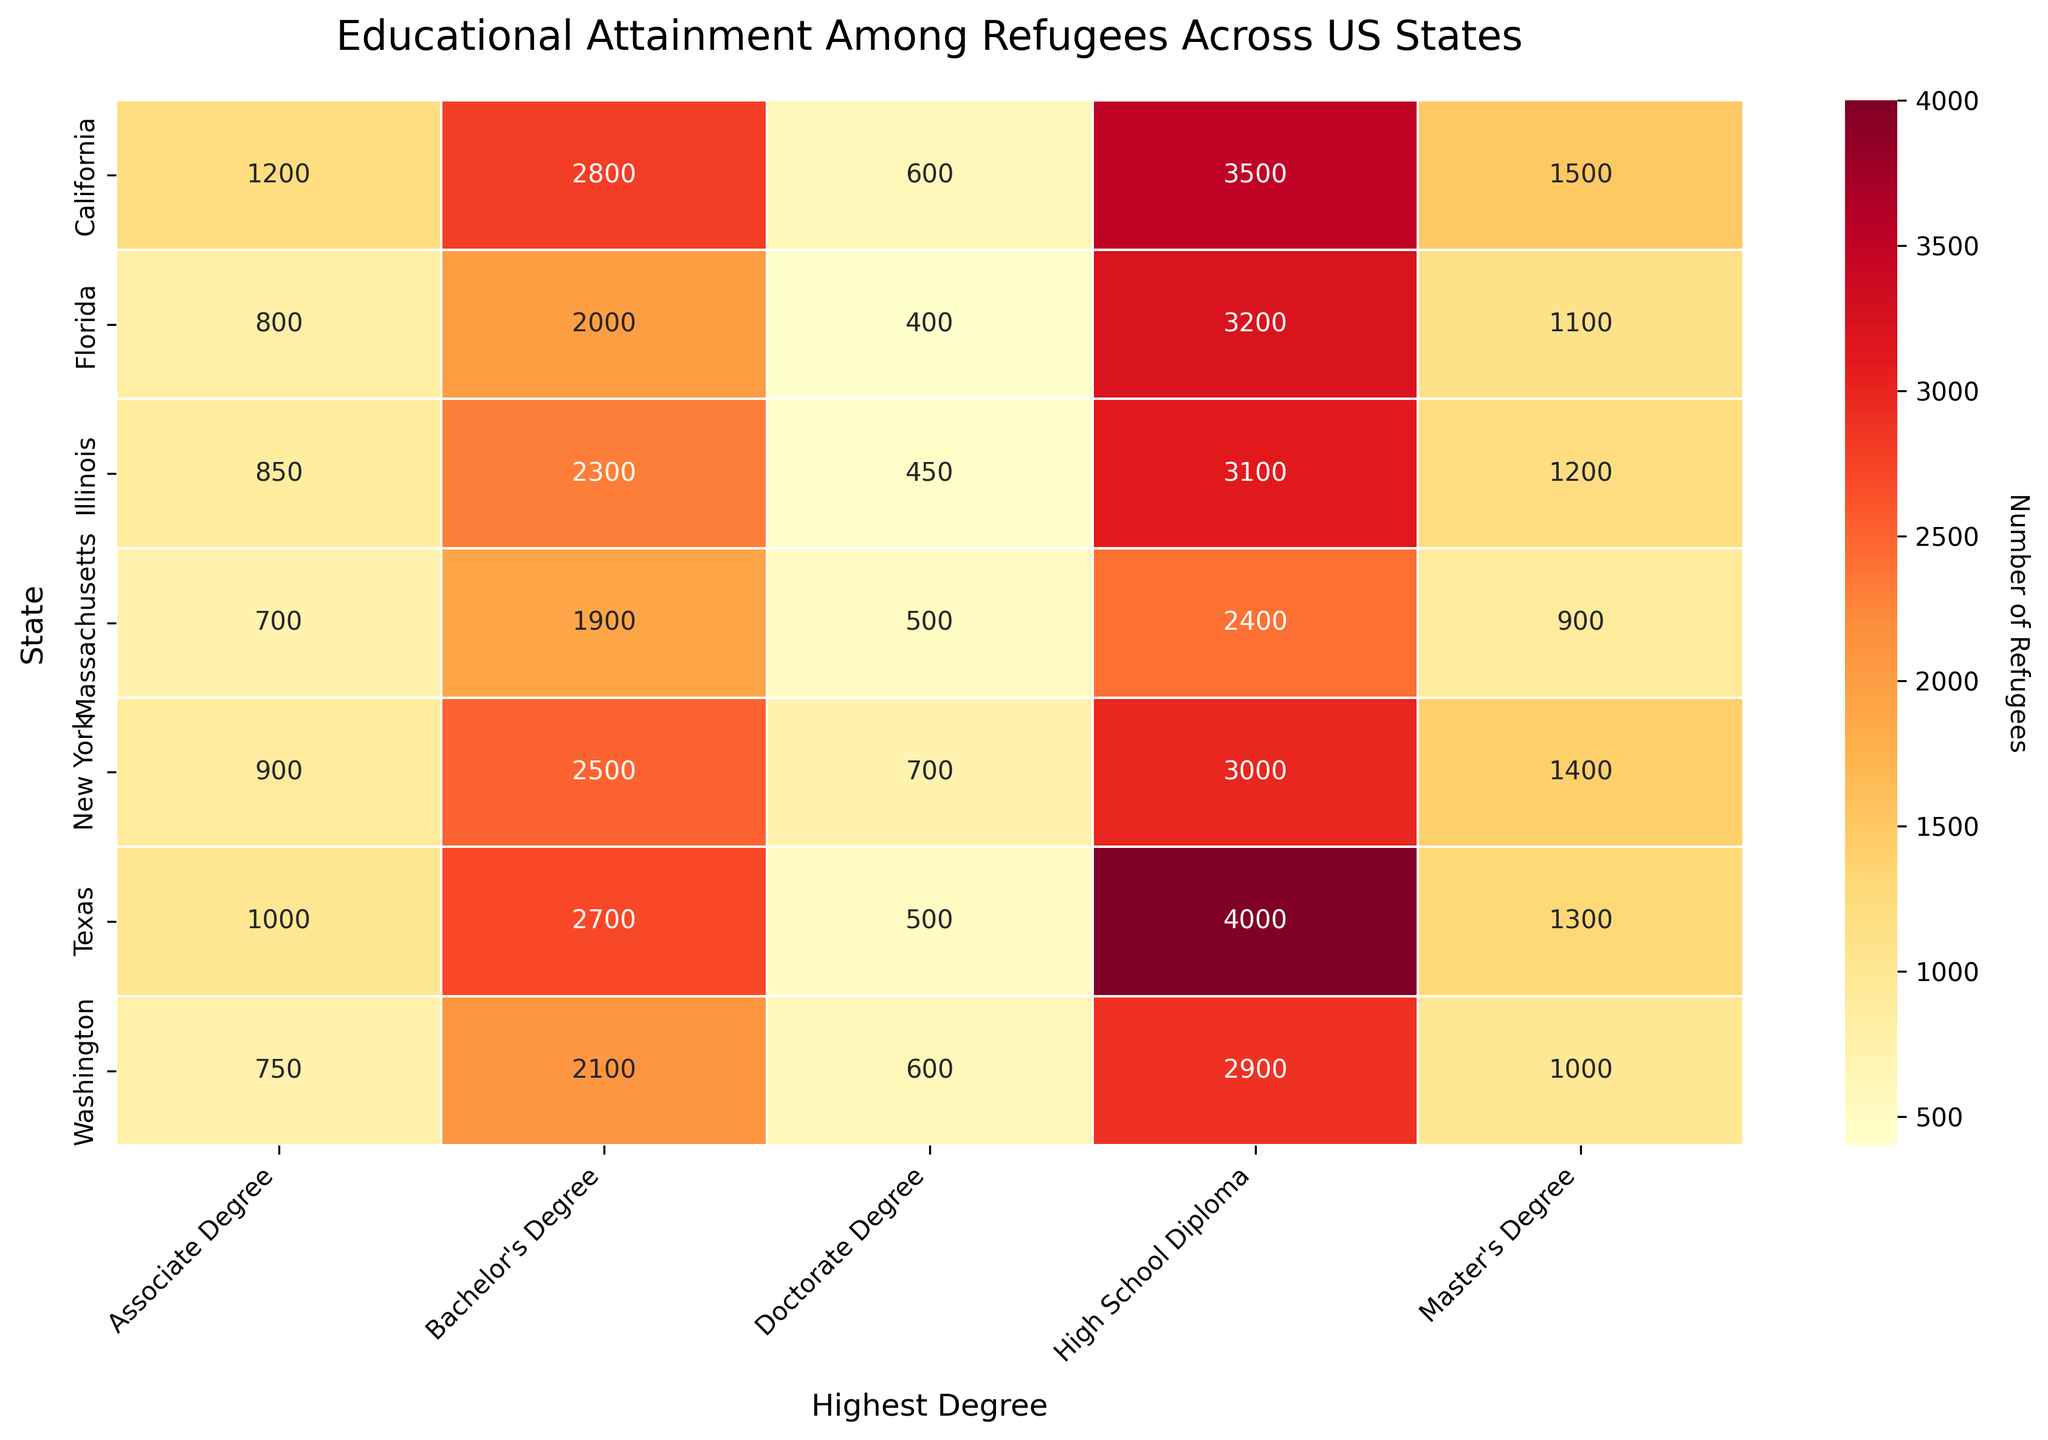what is the title of the heatmap? The title of a heatmap is generally written at the top of the figure, typically in larger and bold text for prominence. By referring to the visual elements, you can identify the title of the heatmap directly from the figure.
Answer: Educational Attainment Among Refugees Across US States How many states are represented in the heatmap? By looking at the y-axis of the heatmap, which lists different states, you can count the number of distinct states displayed.
Answer: Six Which state has the highest number of refugees with a Bachelor's Degree? Examine the color intensities and the annotated numbers within the Bachelor's Degree column to determine which cell has the highest value and refer to the corresponding y-axis label (state).
Answer: California Which state has the fewest number of refugees with a Doctorate Degree? By checking the values in the Doctorate Degree column, identify the smallest number and note the corresponding state on the y-axis.
Answer: Florida What is the sum of refugees with a Master's Degree in California and Texas? Locate the number of refugees with a Master's Degree in California and Texas, then sum these two numbers: 1500 (California) + 1300 (Texas).
Answer: 2800 How does the number of refugees with an Associate Degree in New York compare to Florida? Compare the values in the Associate Degree column for New York and Florida by looking at the respective cells. New York has 900 while Florida has 800.
Answer: New York has 100 more Which degree has the highest number of refugees in Illinois? By scanning the row corresponding to Illinois, identify the degree with the highest value. High School Diploma has 3100, which is the highest.
Answer: High School Diploma What can you say about the color patterns in the heatmap? Observing the color gradient (which goes from light to dark), identify the trends where warmer colors indicate higher values. Describe how these patterns spread across different states and degrees.
Answer: Warmer colors (reds and oranges) signify higher numbers and are more frequent in High School and Bachelor's Degree columns What is the average number of refugees with a Master's Degree across all states? Sum the number of refugees with a Master's Degree in each state: 1500 + 1300 + 1400 + 1100 + 1200 + 1000 + 900 = 8400, then divide by the number of states (6).
Answer: 1200 Which state has the most uniform educational attainment among refugees across different degree categories? By comparing the spread of values within each row, determine which state's numbers are closest to each other, indicating a uniform distribution. Washington shows a more balanced distribution across all degrees than the other states.
Answer: Washington 